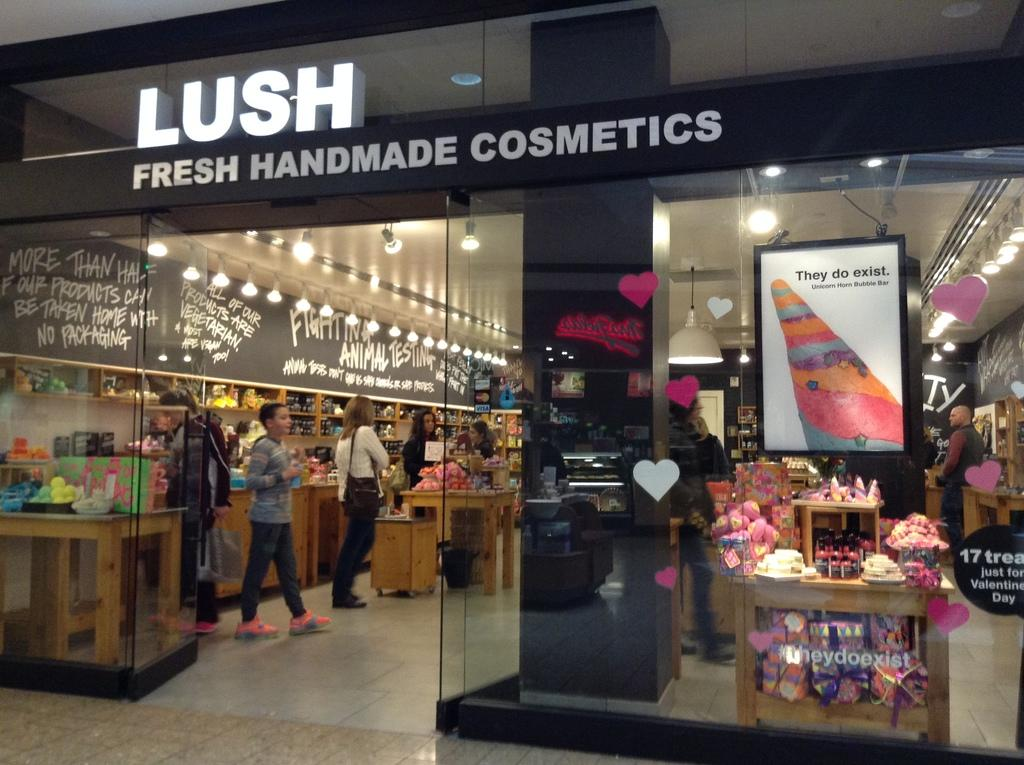<image>
Share a concise interpretation of the image provided. the word Lush with a store behind it 